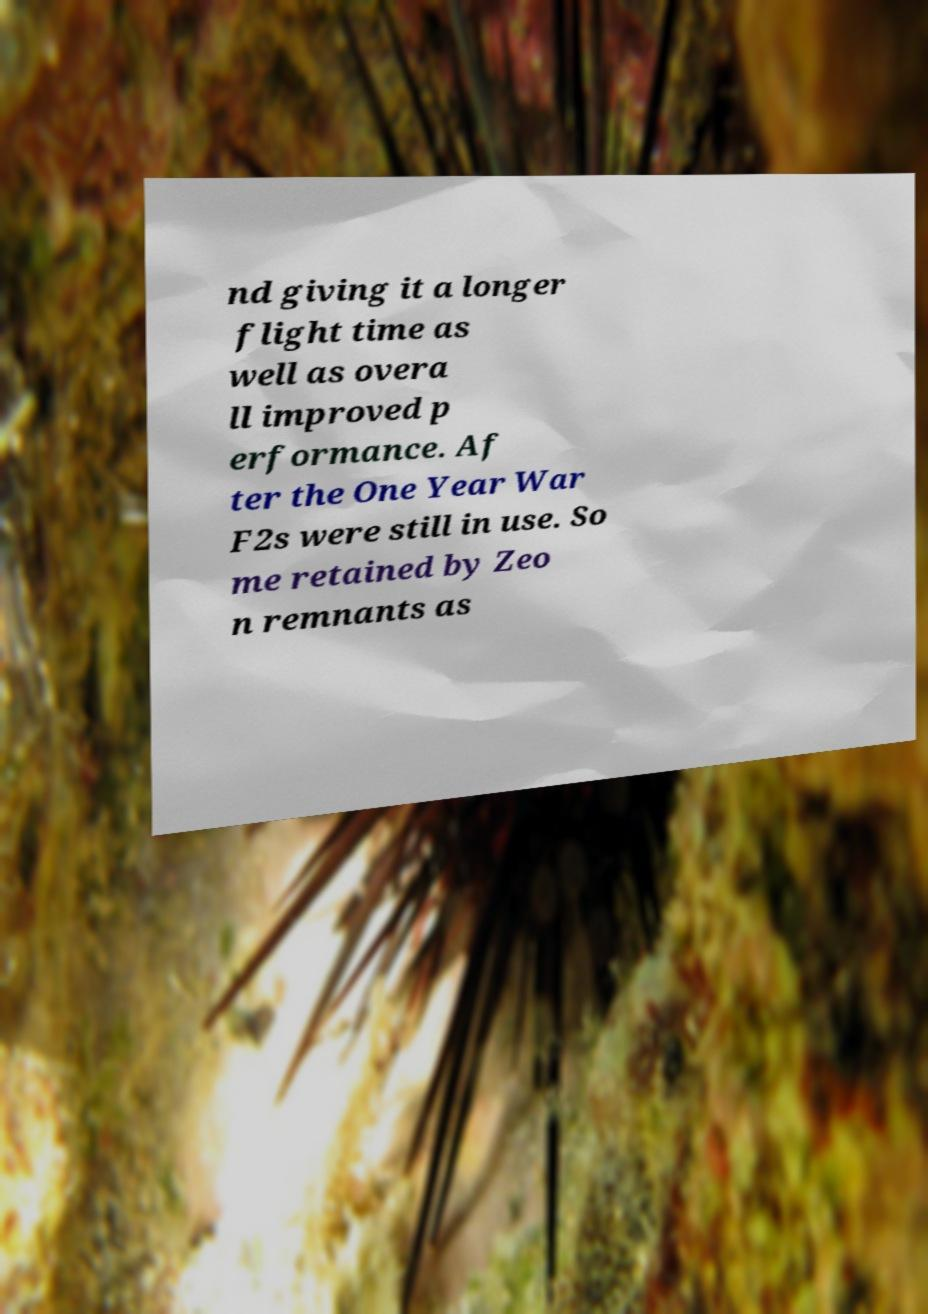Can you read and provide the text displayed in the image?This photo seems to have some interesting text. Can you extract and type it out for me? nd giving it a longer flight time as well as overa ll improved p erformance. Af ter the One Year War F2s were still in use. So me retained by Zeo n remnants as 